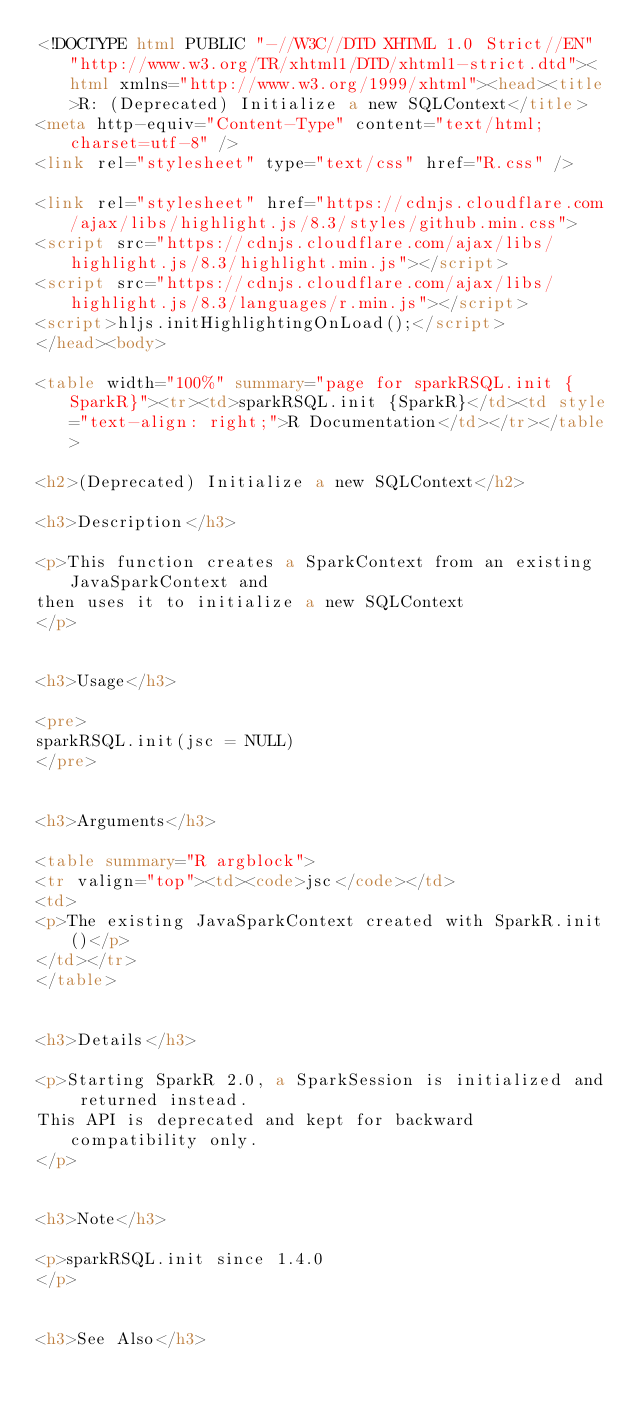<code> <loc_0><loc_0><loc_500><loc_500><_HTML_><!DOCTYPE html PUBLIC "-//W3C//DTD XHTML 1.0 Strict//EN" "http://www.w3.org/TR/xhtml1/DTD/xhtml1-strict.dtd"><html xmlns="http://www.w3.org/1999/xhtml"><head><title>R: (Deprecated) Initialize a new SQLContext</title>
<meta http-equiv="Content-Type" content="text/html; charset=utf-8" />
<link rel="stylesheet" type="text/css" href="R.css" />

<link rel="stylesheet" href="https://cdnjs.cloudflare.com/ajax/libs/highlight.js/8.3/styles/github.min.css">
<script src="https://cdnjs.cloudflare.com/ajax/libs/highlight.js/8.3/highlight.min.js"></script>
<script src="https://cdnjs.cloudflare.com/ajax/libs/highlight.js/8.3/languages/r.min.js"></script>
<script>hljs.initHighlightingOnLoad();</script>
</head><body>

<table width="100%" summary="page for sparkRSQL.init {SparkR}"><tr><td>sparkRSQL.init {SparkR}</td><td style="text-align: right;">R Documentation</td></tr></table>

<h2>(Deprecated) Initialize a new SQLContext</h2>

<h3>Description</h3>

<p>This function creates a SparkContext from an existing JavaSparkContext and
then uses it to initialize a new SQLContext
</p>


<h3>Usage</h3>

<pre>
sparkRSQL.init(jsc = NULL)
</pre>


<h3>Arguments</h3>

<table summary="R argblock">
<tr valign="top"><td><code>jsc</code></td>
<td>
<p>The existing JavaSparkContext created with SparkR.init()</p>
</td></tr>
</table>


<h3>Details</h3>

<p>Starting SparkR 2.0, a SparkSession is initialized and returned instead.
This API is deprecated and kept for backward compatibility only.
</p>


<h3>Note</h3>

<p>sparkRSQL.init since 1.4.0
</p>


<h3>See Also</h3>
</code> 